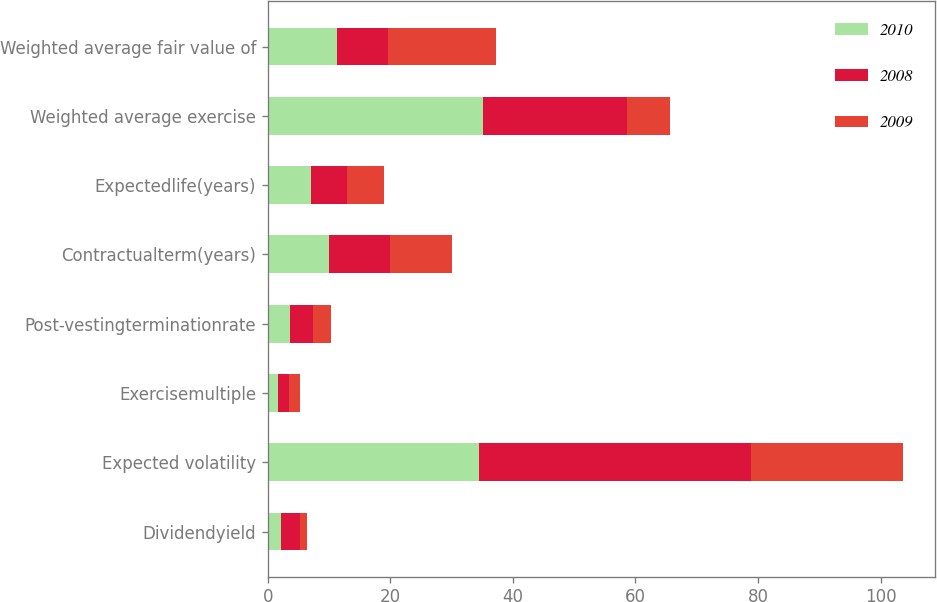Convert chart to OTSL. <chart><loc_0><loc_0><loc_500><loc_500><stacked_bar_chart><ecel><fcel>Dividendyield<fcel>Expected volatility<fcel>Exercisemultiple<fcel>Post-vestingterminationrate<fcel>Contractualterm(years)<fcel>Expectedlife(years)<fcel>Weighted average exercise<fcel>Weighted average fair value of<nl><fcel>2010<fcel>2.11<fcel>34.41<fcel>1.75<fcel>3.64<fcel>10<fcel>7<fcel>35.06<fcel>11.29<nl><fcel>2008<fcel>3.15<fcel>44.39<fcel>1.76<fcel>3.7<fcel>10<fcel>6<fcel>23.61<fcel>8.37<nl><fcel>2009<fcel>1.21<fcel>24.85<fcel>1.73<fcel>3.05<fcel>10<fcel>6<fcel>7<fcel>17.51<nl></chart> 